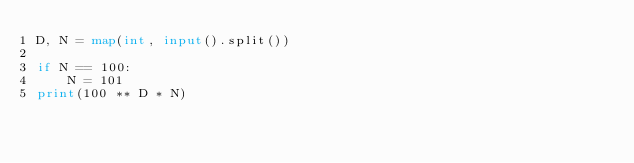Convert code to text. <code><loc_0><loc_0><loc_500><loc_500><_Python_>D, N = map(int, input().split())

if N == 100:
    N = 101
print(100 ** D * N)</code> 